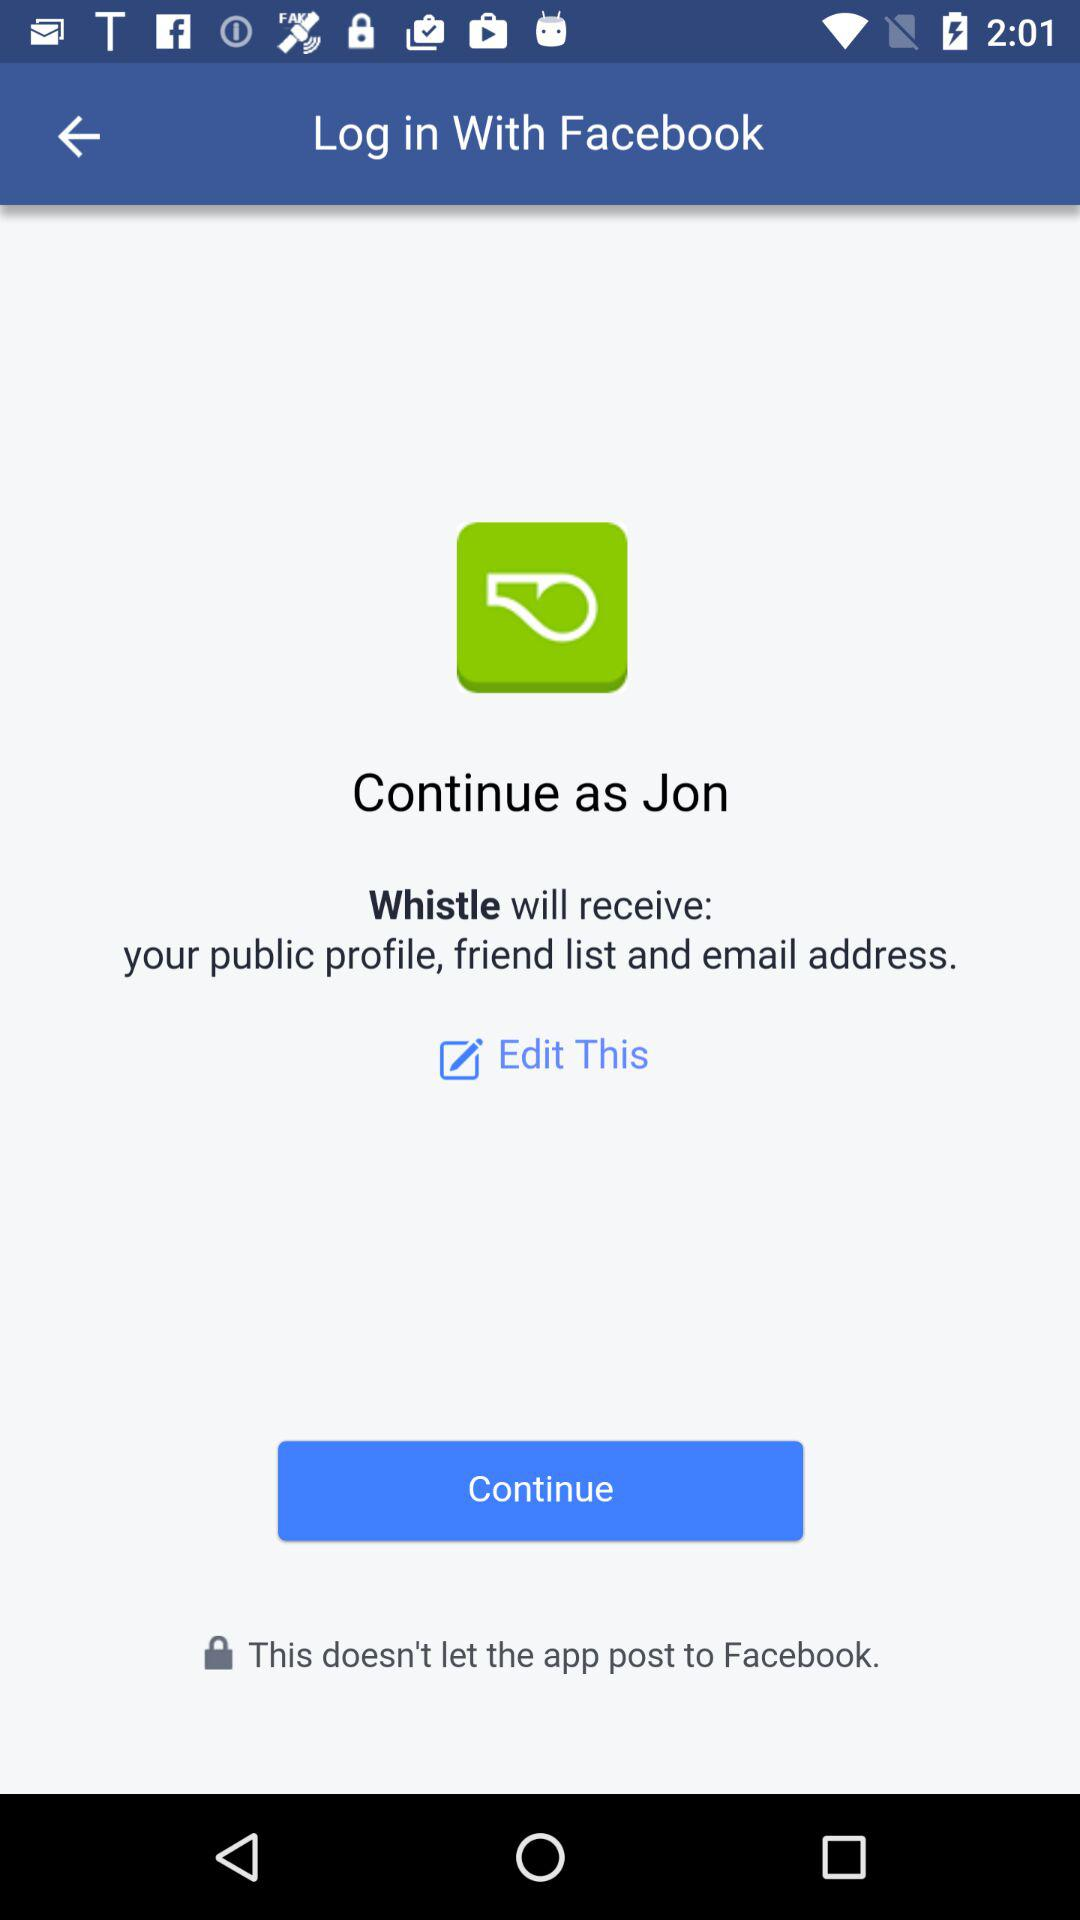What application is asking for permission? The application "Whistle" is asking for permission. 